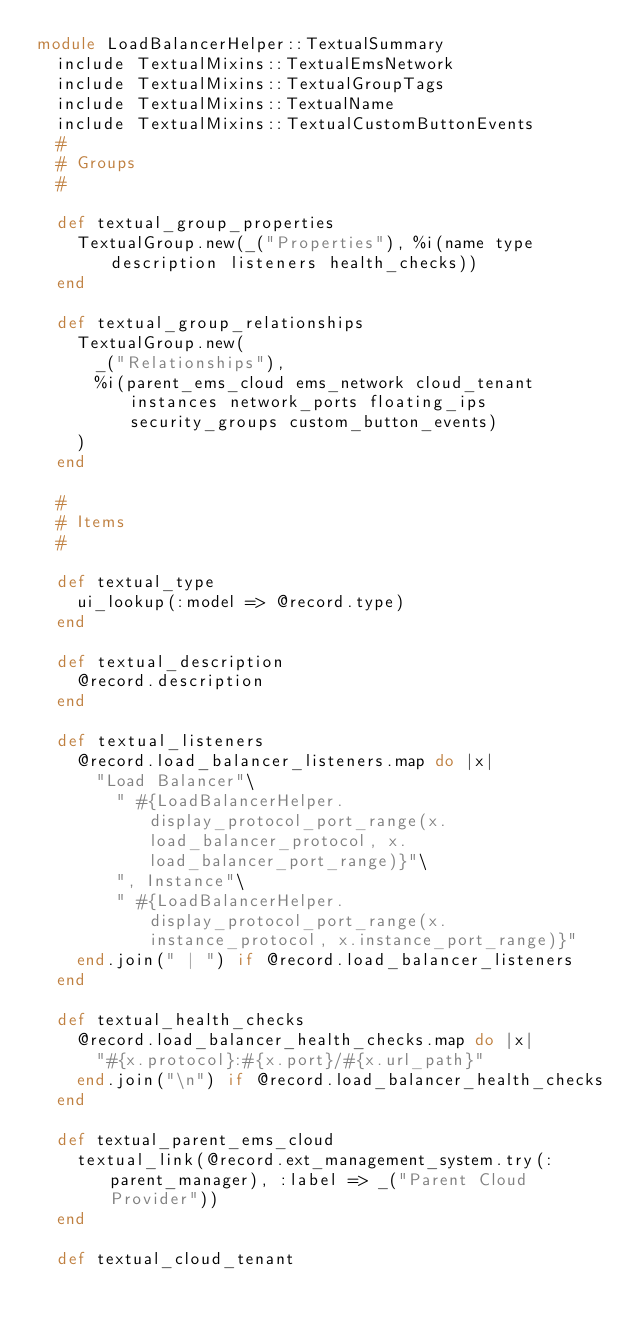<code> <loc_0><loc_0><loc_500><loc_500><_Ruby_>module LoadBalancerHelper::TextualSummary
  include TextualMixins::TextualEmsNetwork
  include TextualMixins::TextualGroupTags
  include TextualMixins::TextualName
  include TextualMixins::TextualCustomButtonEvents
  #
  # Groups
  #

  def textual_group_properties
    TextualGroup.new(_("Properties"), %i(name type description listeners health_checks))
  end

  def textual_group_relationships
    TextualGroup.new(
      _("Relationships"),
      %i(parent_ems_cloud ems_network cloud_tenant instances network_ports floating_ips security_groups custom_button_events)
    )
  end

  #
  # Items
  #

  def textual_type
    ui_lookup(:model => @record.type)
  end

  def textual_description
    @record.description
  end

  def textual_listeners
    @record.load_balancer_listeners.map do |x|
      "Load Balancer"\
        " #{LoadBalancerHelper.display_protocol_port_range(x.load_balancer_protocol, x.load_balancer_port_range)}"\
        ", Instance"\
        " #{LoadBalancerHelper.display_protocol_port_range(x.instance_protocol, x.instance_port_range)}"
    end.join(" | ") if @record.load_balancer_listeners
  end

  def textual_health_checks
    @record.load_balancer_health_checks.map do |x|
      "#{x.protocol}:#{x.port}/#{x.url_path}"
    end.join("\n") if @record.load_balancer_health_checks
  end

  def textual_parent_ems_cloud
    textual_link(@record.ext_management_system.try(:parent_manager), :label => _("Parent Cloud Provider"))
  end

  def textual_cloud_tenant</code> 